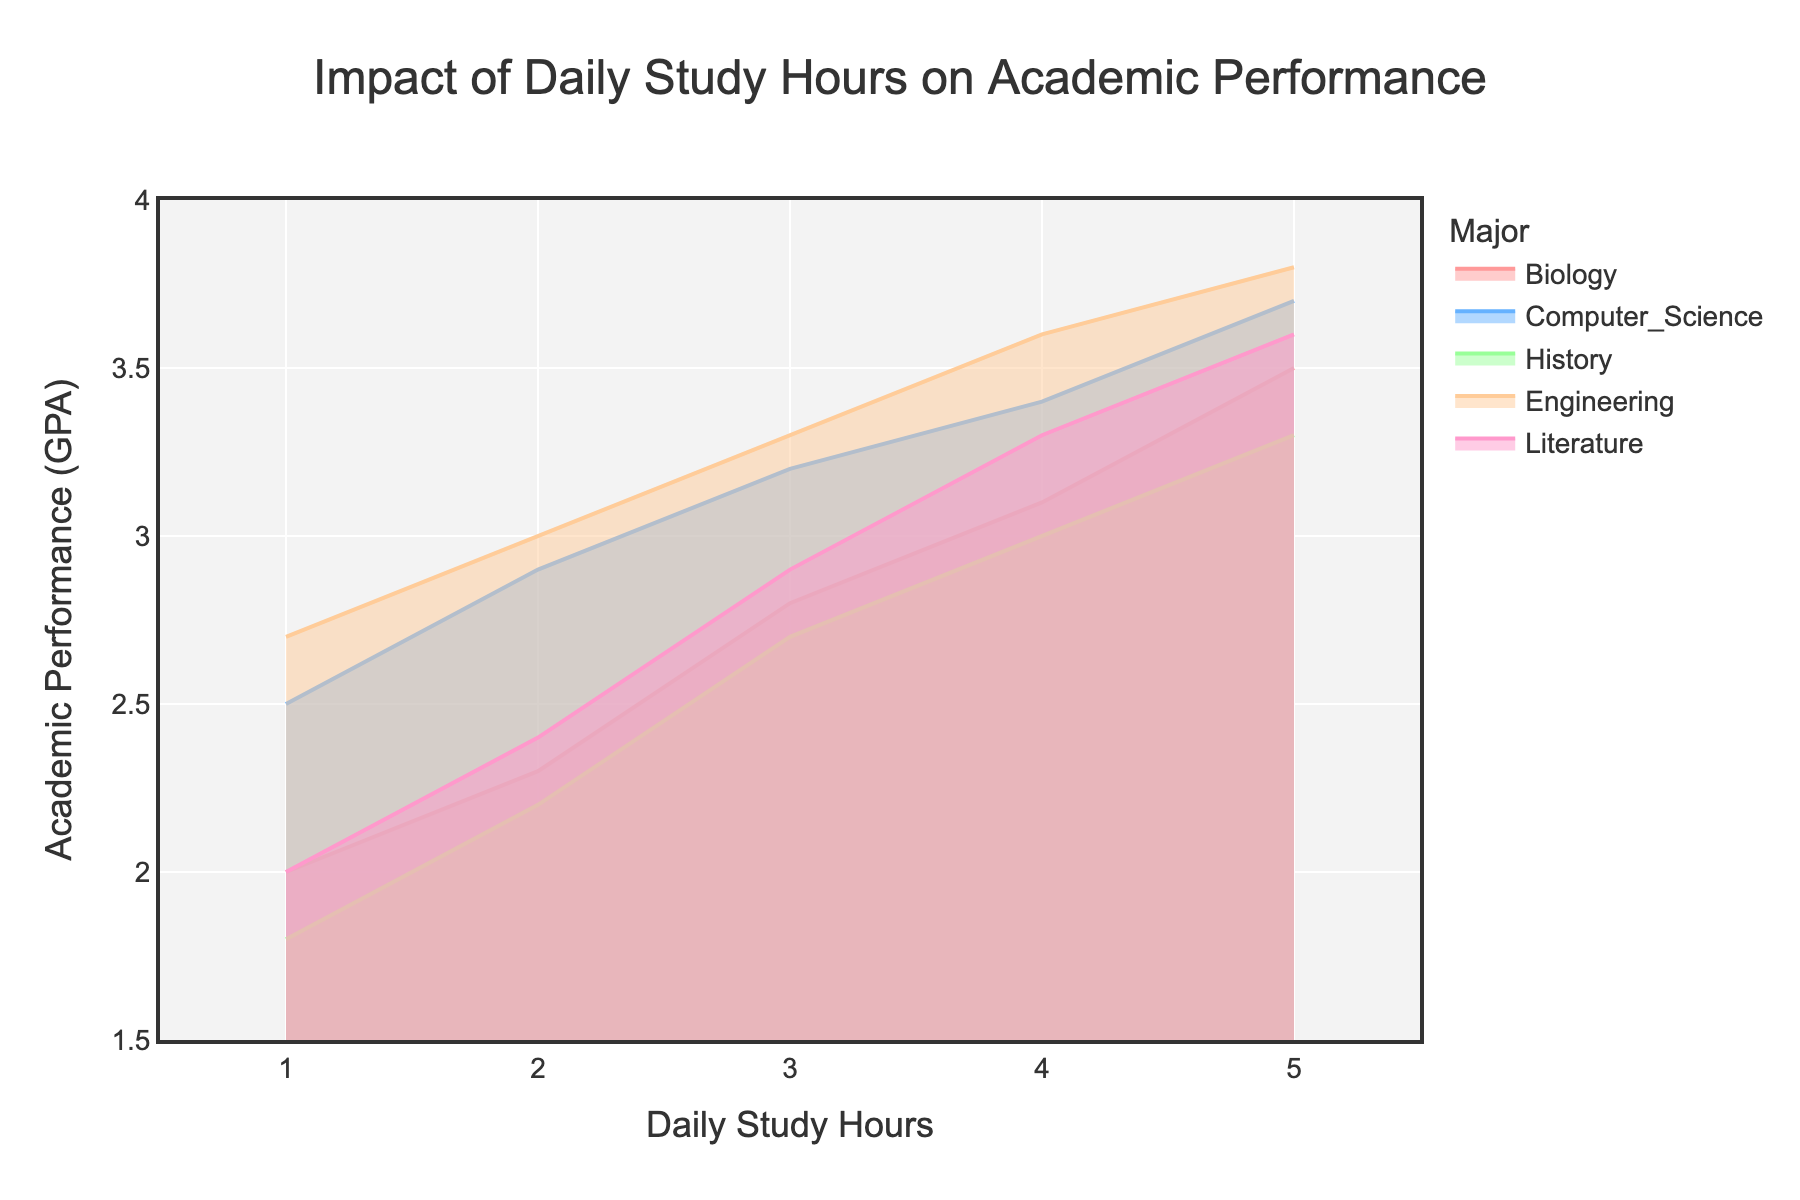What is the major with the highest academic performance for 5 daily study hours? By observing the figure, look at the end points of each line representing the majors at 5 daily study hours. Identify the highest value among them. Engineering has the highest GPA at this point.
Answer: Engineering Which major shows the steepest increase in academic performance from 1 to 2 daily study hours? Analyze the slope of each line between the points for 1 and 2 daily study hours. The steeper the slope, the greater the increase. Computer Science shows a steep increase from 2.5 to 2.9.
Answer: Computer Science What is the academic performance for History with 4 daily study hours? Find the point where the History line intersects with the 4 daily study hours on the x-axis. Read the corresponding y-axis value.
Answer: 3.0 How much does the academic performance for Biology increase from 1 to 5 daily study hours? Find the points for Biology at 1 and 5 daily study hours. Subtract the GPA at 1 study hour from the GPA at 5 study hours.
Answer: 1.5 Which major has the lowest academic performance at 1 daily study hour? Look at the beginning points of each line representing the majors at 1 daily study hour. Identify the lowest value among them.
Answer: History By how much do Computer Science and Engineering differ in academic performance at 3 daily study hours? Find the points for Computer Science and Engineering at 3 daily study hours. Subtract the GPA of Computer Science from the GPA of Engineering.
Answer: 0.1 Which major has the most consistent increase in academic performance as study hours increase? Observe the lines for each major and identify the one with the most linear and consistent increase without sharp changes in slope.
Answer: Engineering How does the academic performance of Literature change as daily study hours increase from 2 to 4? Observe the points on the Literature line at 2 and 4 daily study hours and see the changes in GPA. It increases from 2.4 to 3.3.
Answer: It increases What is the difference in academic performance between Biology and Literature at 5 daily study hours? Find the end points for Biology and Literature at 5 daily study hours. Subtract the GPA of Biology from the GPA of Literature.
Answer: 0.1 Who has a higher academic performance at 2 daily study hours, History or Literature? Compare the points on the History and Literature lines at 2 daily study hours. Check which one has a higher GPA value.
Answer: Literature 